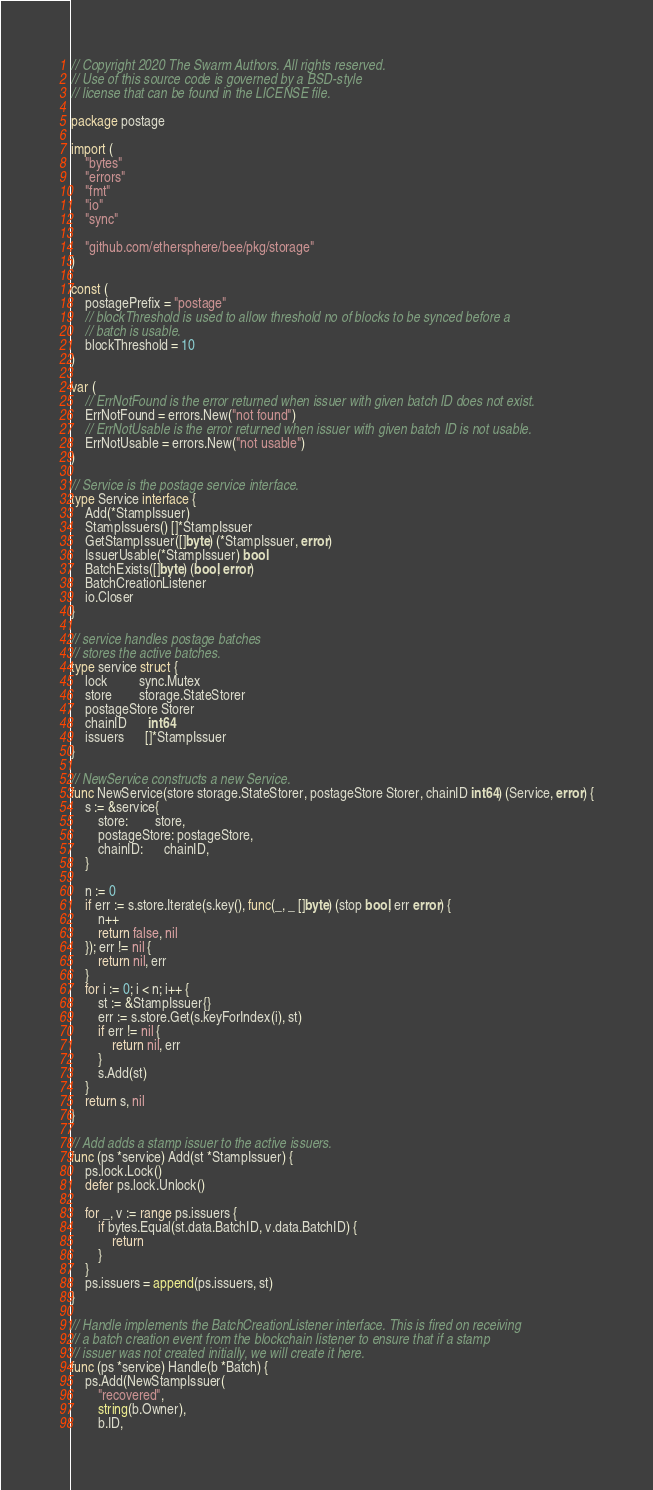<code> <loc_0><loc_0><loc_500><loc_500><_Go_>// Copyright 2020 The Swarm Authors. All rights reserved.
// Use of this source code is governed by a BSD-style
// license that can be found in the LICENSE file.

package postage

import (
	"bytes"
	"errors"
	"fmt"
	"io"
	"sync"

	"github.com/ethersphere/bee/pkg/storage"
)

const (
	postagePrefix = "postage"
	// blockThreshold is used to allow threshold no of blocks to be synced before a
	// batch is usable.
	blockThreshold = 10
)

var (
	// ErrNotFound is the error returned when issuer with given batch ID does not exist.
	ErrNotFound = errors.New("not found")
	// ErrNotUsable is the error returned when issuer with given batch ID is not usable.
	ErrNotUsable = errors.New("not usable")
)

// Service is the postage service interface.
type Service interface {
	Add(*StampIssuer)
	StampIssuers() []*StampIssuer
	GetStampIssuer([]byte) (*StampIssuer, error)
	IssuerUsable(*StampIssuer) bool
	BatchExists([]byte) (bool, error)
	BatchCreationListener
	io.Closer
}

// service handles postage batches
// stores the active batches.
type service struct {
	lock         sync.Mutex
	store        storage.StateStorer
	postageStore Storer
	chainID      int64
	issuers      []*StampIssuer
}

// NewService constructs a new Service.
func NewService(store storage.StateStorer, postageStore Storer, chainID int64) (Service, error) {
	s := &service{
		store:        store,
		postageStore: postageStore,
		chainID:      chainID,
	}

	n := 0
	if err := s.store.Iterate(s.key(), func(_, _ []byte) (stop bool, err error) {
		n++
		return false, nil
	}); err != nil {
		return nil, err
	}
	for i := 0; i < n; i++ {
		st := &StampIssuer{}
		err := s.store.Get(s.keyForIndex(i), st)
		if err != nil {
			return nil, err
		}
		s.Add(st)
	}
	return s, nil
}

// Add adds a stamp issuer to the active issuers.
func (ps *service) Add(st *StampIssuer) {
	ps.lock.Lock()
	defer ps.lock.Unlock()

	for _, v := range ps.issuers {
		if bytes.Equal(st.data.BatchID, v.data.BatchID) {
			return
		}
	}
	ps.issuers = append(ps.issuers, st)
}

// Handle implements the BatchCreationListener interface. This is fired on receiving
// a batch creation event from the blockchain listener to ensure that if a stamp
// issuer was not created initially, we will create it here.
func (ps *service) Handle(b *Batch) {
	ps.Add(NewStampIssuer(
		"recovered",
		string(b.Owner),
		b.ID,</code> 